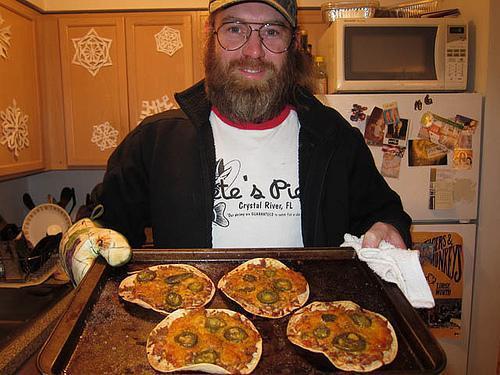How many men are there?
Give a very brief answer. 1. How many pizzas are there?
Give a very brief answer. 4. How many microwaves are in the picture?
Give a very brief answer. 1. 